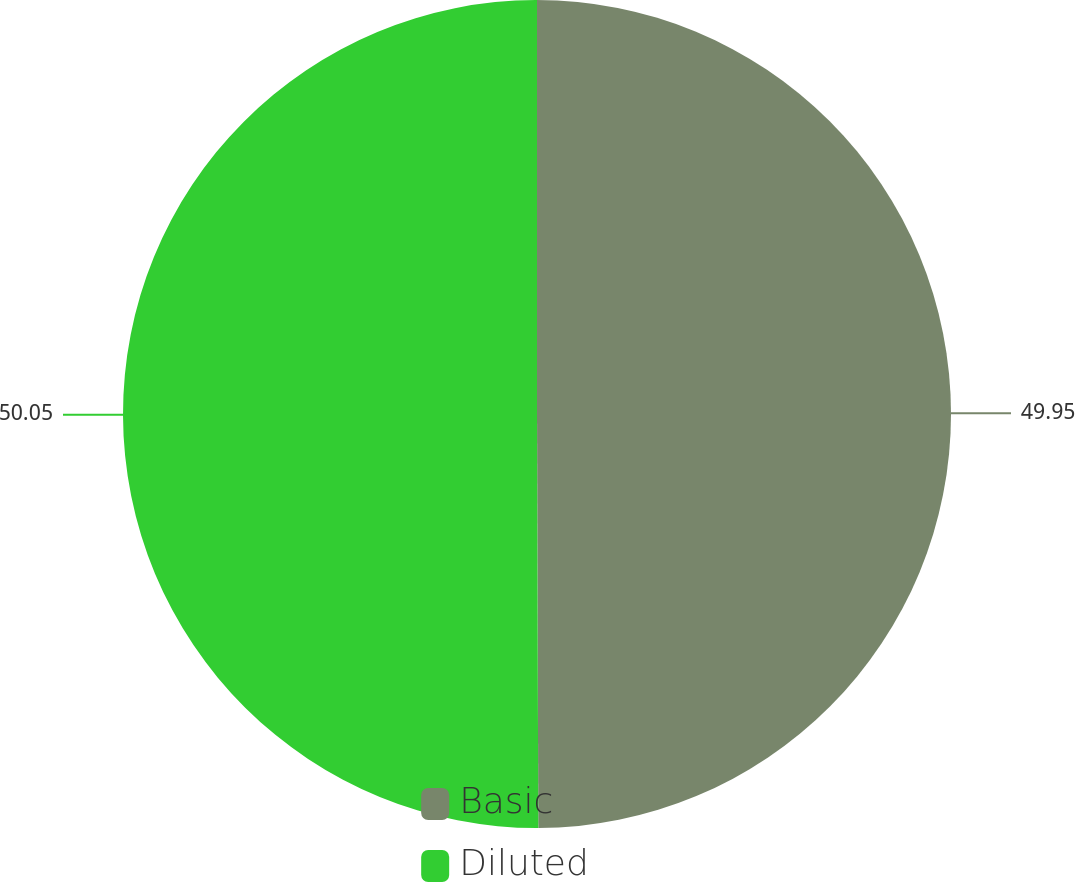Convert chart to OTSL. <chart><loc_0><loc_0><loc_500><loc_500><pie_chart><fcel>Basic<fcel>Diluted<nl><fcel>49.95%<fcel>50.05%<nl></chart> 